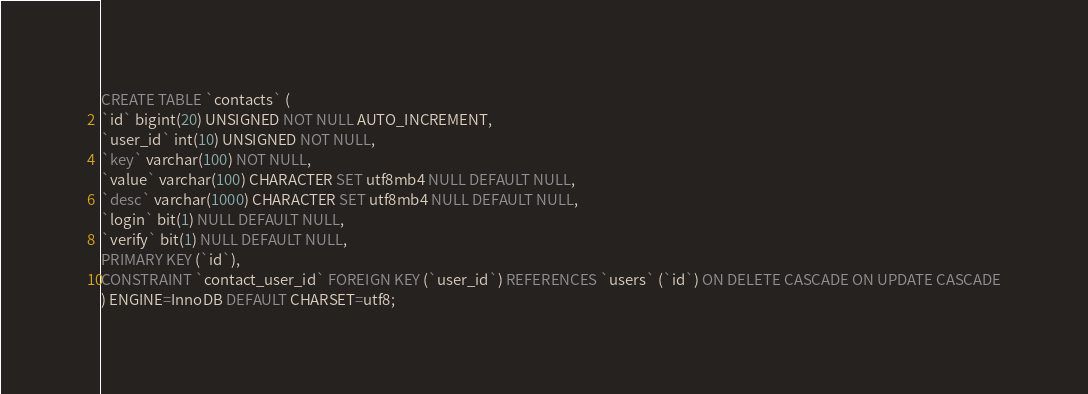Convert code to text. <code><loc_0><loc_0><loc_500><loc_500><_SQL_>CREATE TABLE `contacts` (
`id` bigint(20) UNSIGNED NOT NULL AUTO_INCREMENT,
`user_id` int(10) UNSIGNED NOT NULL,
`key` varchar(100) NOT NULL,
`value` varchar(100) CHARACTER SET utf8mb4 NULL DEFAULT NULL,
`desc` varchar(1000) CHARACTER SET utf8mb4 NULL DEFAULT NULL,
`login` bit(1) NULL DEFAULT NULL,
`verify` bit(1) NULL DEFAULT NULL,
PRIMARY KEY (`id`),
CONSTRAINT `contact_user_id` FOREIGN KEY (`user_id`) REFERENCES `users` (`id`) ON DELETE CASCADE ON UPDATE CASCADE
) ENGINE=InnoDB DEFAULT CHARSET=utf8;</code> 